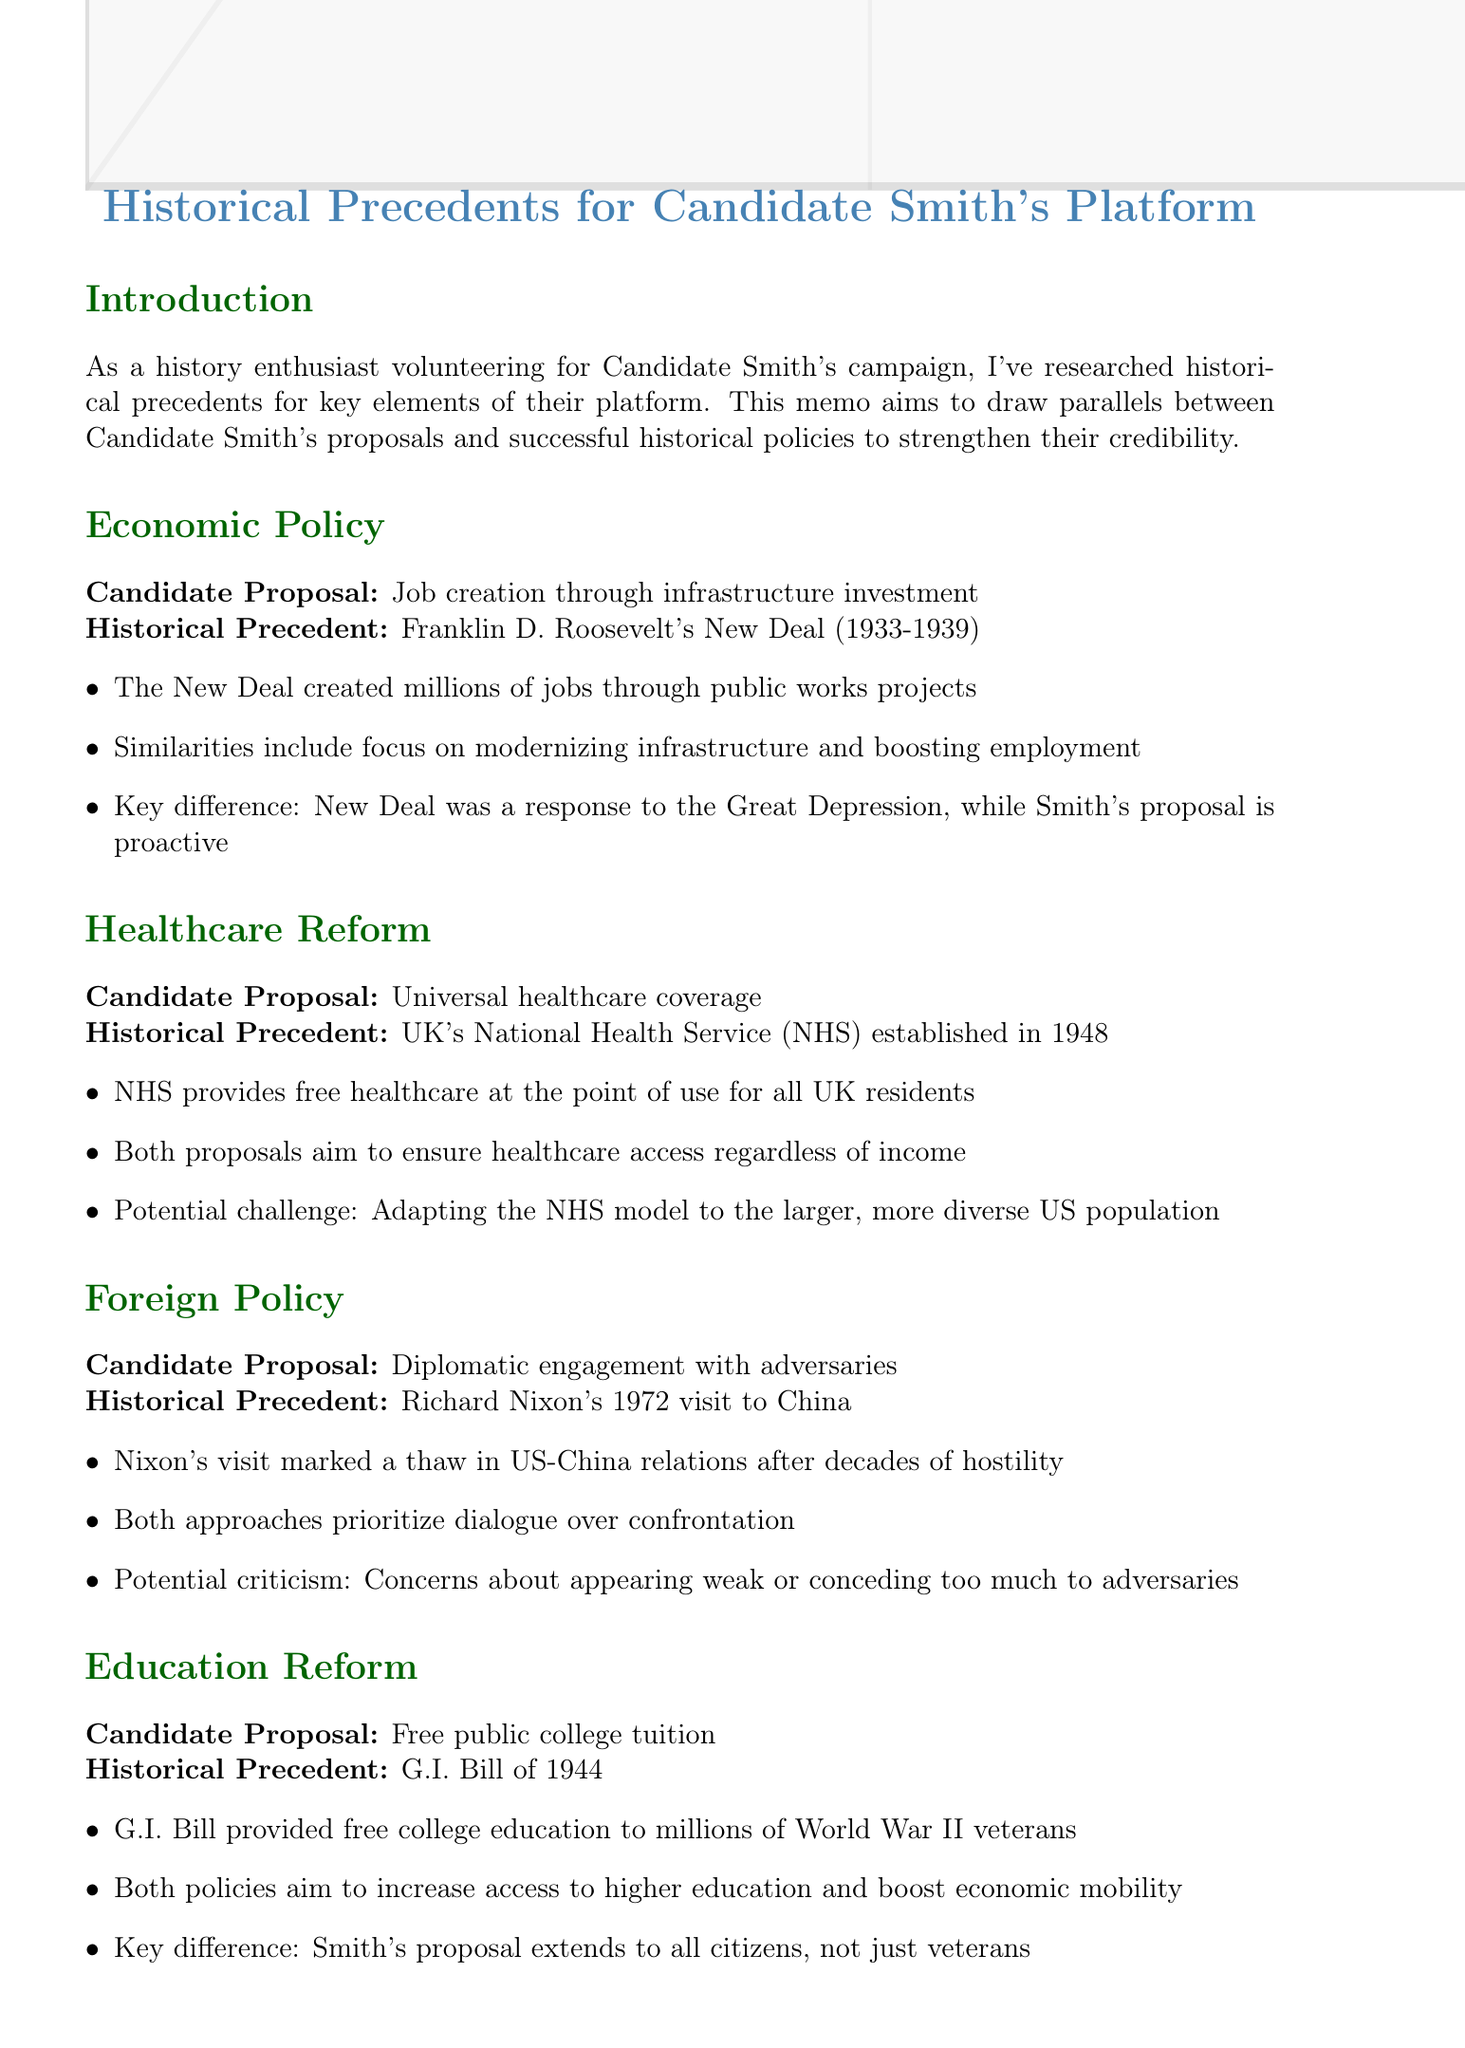What is the title of the memo? The title of the memo is explicitly stated at the beginning of the document.
Answer: Historical Precedents for Candidate Smith's Platform Who is the candidate discussed in this memo? The candidate's name is mentioned throughout the memo as part of the comparisons made.
Answer: Candidate Smith What economic policy does Candidate Smith propose? The memo outlines the candidate's proposal under the economic policy section.
Answer: Job creation through infrastructure investment Which historical precedent is linked to healthcare reform? The healthcare reform section specifies the historical example that aligns with Candidate Smith's proposal.
Answer: UK's National Health Service (NHS) established in 1948 What significant legislation is compared to Candidate Smith's education reform proposal? The education reform section identifies a specific historical bill used for comparison.
Answer: G.I. Bill of 1944 How many sources are listed at the end of the memo? The total number of sources can be counted from the sources section at the memo's conclusion.
Answer: Four What is a key difference in Candidate Smith's economic policy compared to the New Deal? The document states differing contexts between the New Deal and Smith's proposal in terms of response.
Answer: Proactive What main goal is shared between Candidate Smith's health care proposal and the NHS? The memo outlines the common objective shared between both proposals under the healthcare section.
Answer: Ensure healthcare access regardless of income What recommendation is given at the end of the memo? The memo concludes with a specific action that should be taken in the campaign messaging.
Answer: Emphasize these historical parallels in campaign messaging 